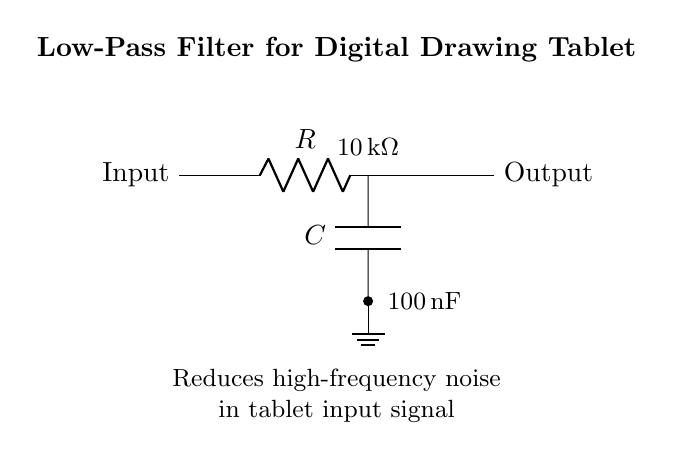What is the value of the resistor? The resistor's value is labeled in the circuit diagram as 10 kΩ. You can see it is marked on the resistor symbol in the diagram.
Answer: 10 kΩ What component is connected in parallel with the output? In this circuit diagram, there is no component connected in parallel with the output; only the capacitor is connected in series after the resistor.
Answer: None What type of filter is shown in this circuit? The circuit diagram represents a low-pass filter, as indicated by the title and the arrangement of components designed to allow low-frequency signals to pass while attenuating high-frequency noise.
Answer: Low-pass filter What is the value of the capacitor? The value of the capacitor is indicated on the component symbol as 100 nF. This information is also labeled next to the capacitor in the diagram.
Answer: 100 nF What is the purpose of this circuit? The circuit is designed to reduce high-frequency noise in the tablet input signal, as described in the explanation under the diagram.
Answer: Reduce noise What happens to high-frequency signals in this filter? High-frequency signals are attenuated, meaning they are reduced in amplitude as they try to pass through the low-pass filter. This is the primary function of such a filter.
Answer: Attenuated What is the output of the circuit relative to the input? The output of this circuit is a smoother signal with reduced high-frequency noise compared to the input signal, thus the output is cleaner.
Answer: Smoother signal 